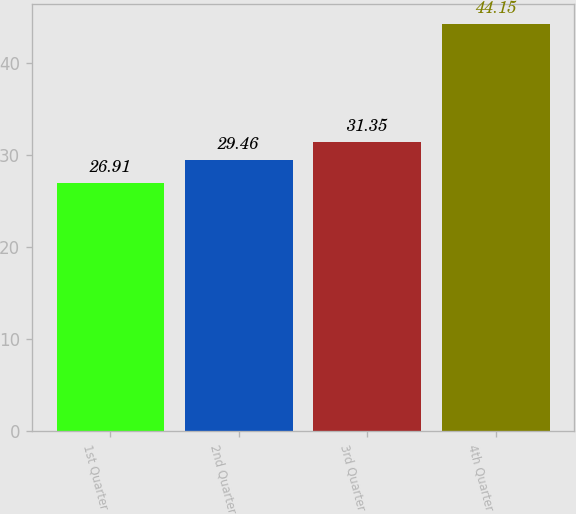<chart> <loc_0><loc_0><loc_500><loc_500><bar_chart><fcel>1st Quarter<fcel>2nd Quarter<fcel>3rd Quarter<fcel>4th Quarter<nl><fcel>26.91<fcel>29.46<fcel>31.35<fcel>44.15<nl></chart> 